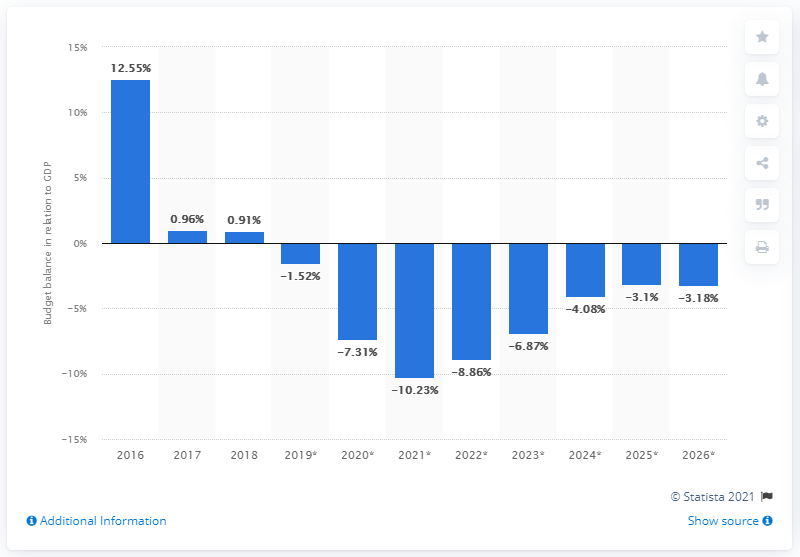Indicate a few pertinent items in this graphic. Iceland's budget surplus, which amounted to 0.91 percent of the country's GDP in 2018, was a significant contributor to the overall growth of the economy. 